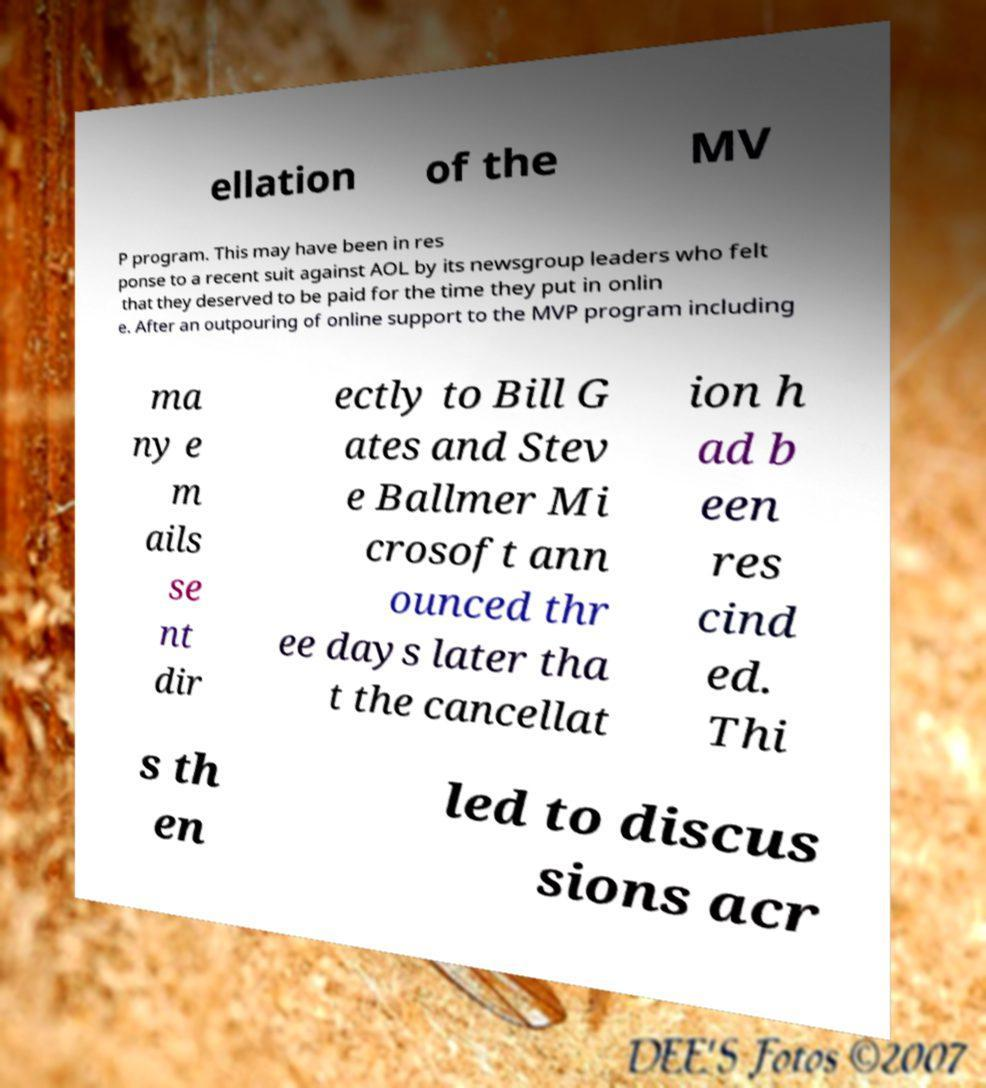Could you assist in decoding the text presented in this image and type it out clearly? ellation of the MV P program. This may have been in res ponse to a recent suit against AOL by its newsgroup leaders who felt that they deserved to be paid for the time they put in onlin e. After an outpouring of online support to the MVP program including ma ny e m ails se nt dir ectly to Bill G ates and Stev e Ballmer Mi crosoft ann ounced thr ee days later tha t the cancellat ion h ad b een res cind ed. Thi s th en led to discus sions acr 